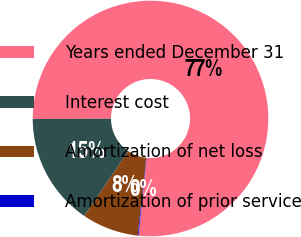Convert chart. <chart><loc_0><loc_0><loc_500><loc_500><pie_chart><fcel>Years ended December 31<fcel>Interest cost<fcel>Amortization of net loss<fcel>Amortization of prior service<nl><fcel>76.69%<fcel>15.43%<fcel>7.77%<fcel>0.11%<nl></chart> 